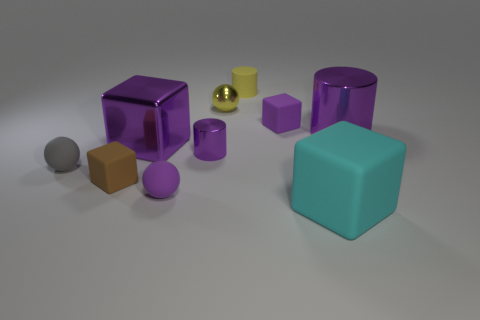There is a rubber cube that is in front of the big purple cylinder and on the left side of the big cyan rubber block; how big is it?
Your answer should be very brief. Small. There is a matte object that is on the left side of the big purple metal block and to the right of the small gray matte ball; what color is it?
Offer a very short reply. Brown. Are there fewer yellow things that are to the right of the small purple matte block than yellow metal balls that are left of the large purple block?
Provide a short and direct response. No. What number of tiny yellow things have the same shape as the gray thing?
Offer a terse response. 1. What size is the purple cube that is the same material as the small yellow ball?
Offer a terse response. Large. There is a small block in front of the tiny matte block to the right of the yellow sphere; what is its color?
Your answer should be very brief. Brown. Does the small brown matte thing have the same shape as the tiny object that is in front of the brown block?
Provide a short and direct response. No. Are there the same number of yellow metal objects and large red blocks?
Make the answer very short. No. What number of cyan objects are the same size as the purple metal block?
Your response must be concise. 1. There is another big object that is the same shape as the large cyan matte object; what is its material?
Provide a succinct answer. Metal. 